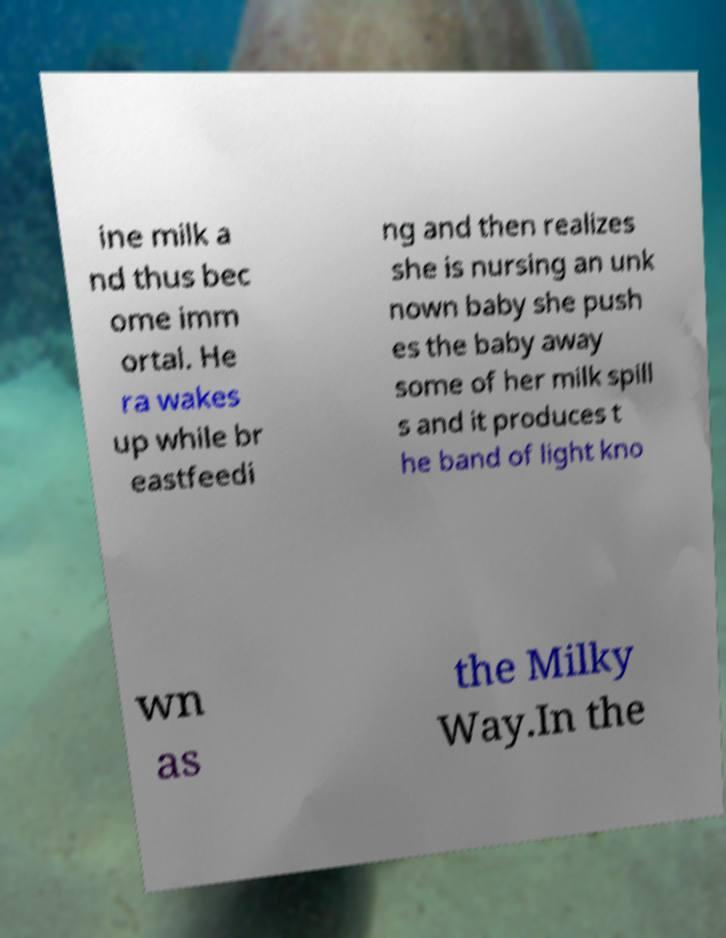Please read and relay the text visible in this image. What does it say? ine milk a nd thus bec ome imm ortal. He ra wakes up while br eastfeedi ng and then realizes she is nursing an unk nown baby she push es the baby away some of her milk spill s and it produces t he band of light kno wn as the Milky Way.In the 